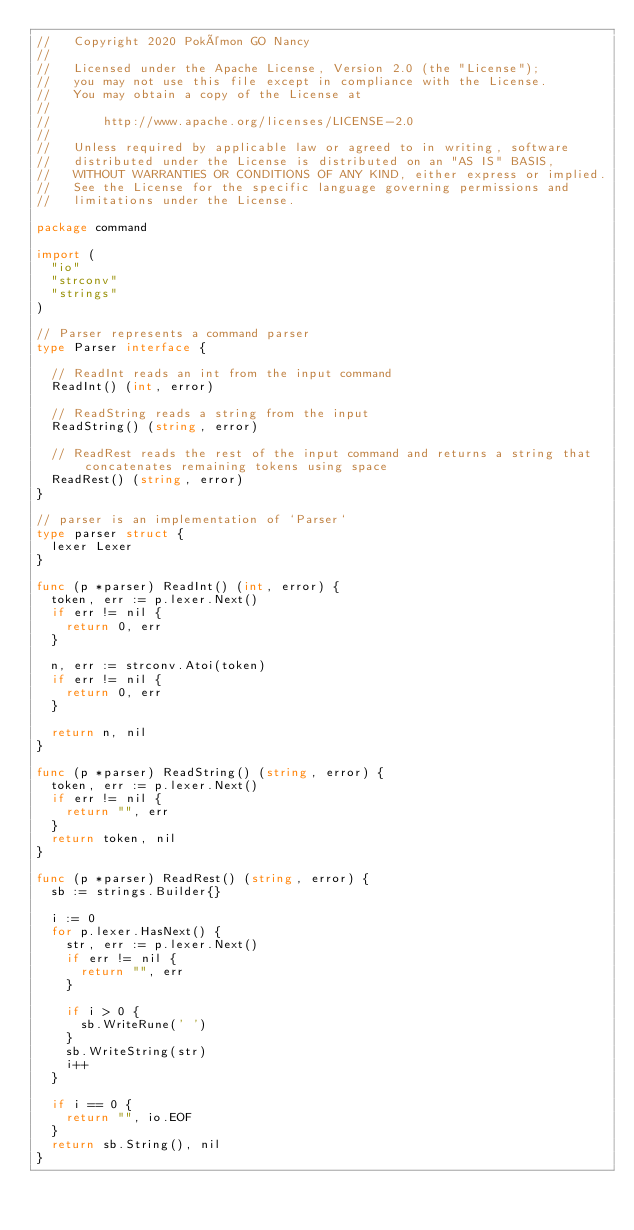Convert code to text. <code><loc_0><loc_0><loc_500><loc_500><_Go_>//   Copyright 2020 Pokémon GO Nancy
//
//   Licensed under the Apache License, Version 2.0 (the "License");
//   you may not use this file except in compliance with the License.
//   You may obtain a copy of the License at
//
//       http://www.apache.org/licenses/LICENSE-2.0
//
//   Unless required by applicable law or agreed to in writing, software
//   distributed under the License is distributed on an "AS IS" BASIS,
//   WITHOUT WARRANTIES OR CONDITIONS OF ANY KIND, either express or implied.
//   See the License for the specific language governing permissions and
//   limitations under the License.

package command

import (
	"io"
	"strconv"
	"strings"
)

// Parser represents a command parser
type Parser interface {

	// ReadInt reads an int from the input command
	ReadInt() (int, error)

	// ReadString reads a string from the input
	ReadString() (string, error)

	// ReadRest reads the rest of the input command and returns a string that concatenates remaining tokens using space
	ReadRest() (string, error)
}

// parser is an implementation of `Parser`
type parser struct {
	lexer Lexer
}

func (p *parser) ReadInt() (int, error) {
	token, err := p.lexer.Next()
	if err != nil {
		return 0, err
	}

	n, err := strconv.Atoi(token)
	if err != nil {
		return 0, err
	}

	return n, nil
}

func (p *parser) ReadString() (string, error) {
	token, err := p.lexer.Next()
	if err != nil {
		return "", err
	}
	return token, nil
}

func (p *parser) ReadRest() (string, error) {
	sb := strings.Builder{}

	i := 0
	for p.lexer.HasNext() {
		str, err := p.lexer.Next()
		if err != nil {
			return "", err
		}

		if i > 0 {
			sb.WriteRune(' ')
		}
		sb.WriteString(str)
		i++
	}

	if i == 0 {
		return "", io.EOF
	}
	return sb.String(), nil
}
</code> 